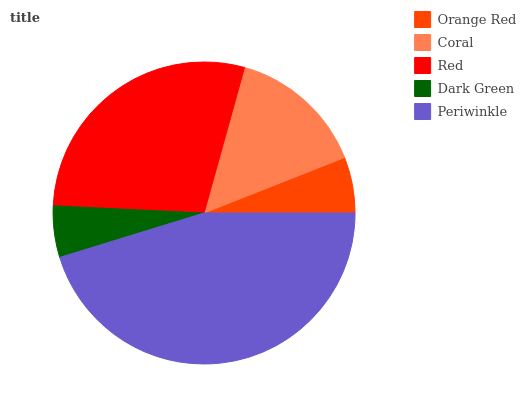Is Dark Green the minimum?
Answer yes or no. Yes. Is Periwinkle the maximum?
Answer yes or no. Yes. Is Coral the minimum?
Answer yes or no. No. Is Coral the maximum?
Answer yes or no. No. Is Coral greater than Orange Red?
Answer yes or no. Yes. Is Orange Red less than Coral?
Answer yes or no. Yes. Is Orange Red greater than Coral?
Answer yes or no. No. Is Coral less than Orange Red?
Answer yes or no. No. Is Coral the high median?
Answer yes or no. Yes. Is Coral the low median?
Answer yes or no. Yes. Is Periwinkle the high median?
Answer yes or no. No. Is Dark Green the low median?
Answer yes or no. No. 